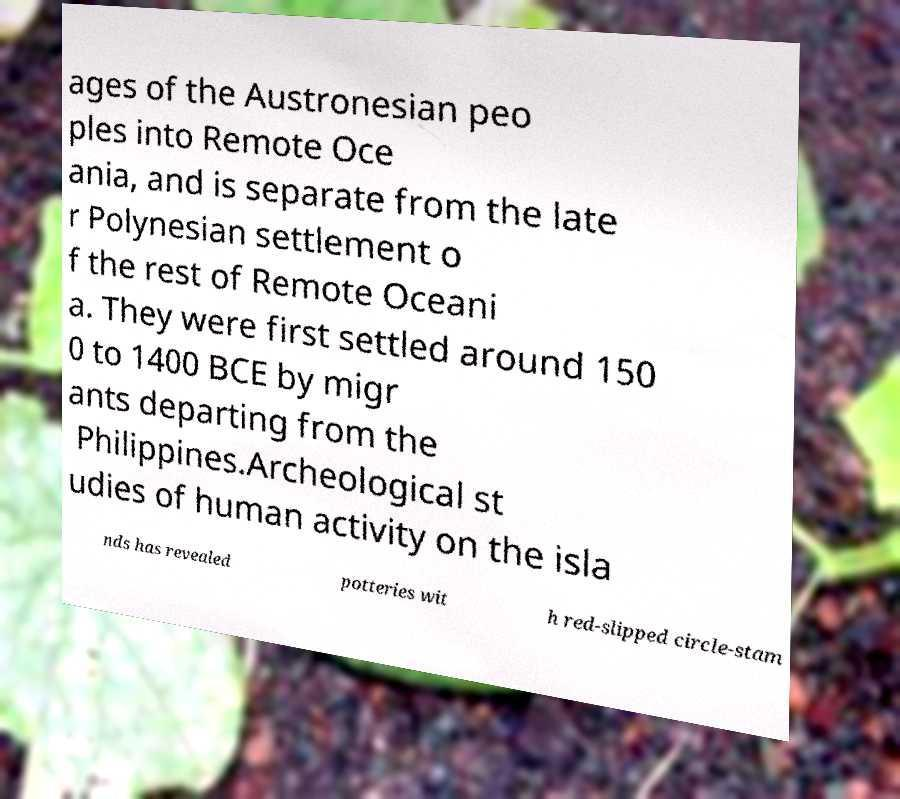Could you assist in decoding the text presented in this image and type it out clearly? ages of the Austronesian peo ples into Remote Oce ania, and is separate from the late r Polynesian settlement o f the rest of Remote Oceani a. They were first settled around 150 0 to 1400 BCE by migr ants departing from the Philippines.Archeological st udies of human activity on the isla nds has revealed potteries wit h red-slipped circle-stam 